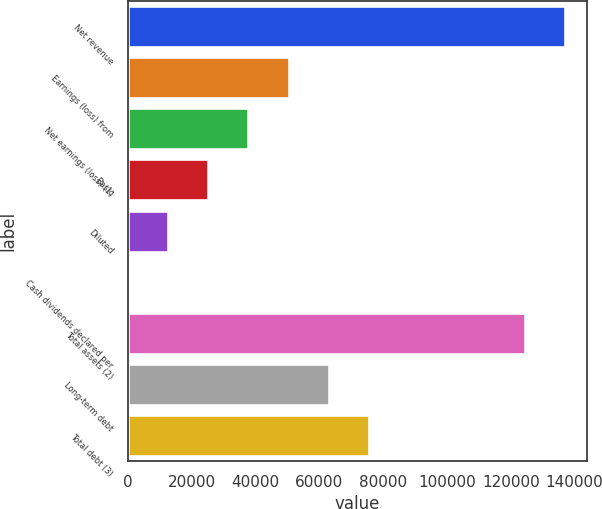Convert chart to OTSL. <chart><loc_0><loc_0><loc_500><loc_500><bar_chart><fcel>Net revenue<fcel>Earnings (loss) from<fcel>Net earnings (loss) (1)<fcel>Basic<fcel>Diluted<fcel>Cash dividends declared per<fcel>Total assets (2)<fcel>Long-term debt<fcel>Total debt (3)<nl><fcel>137106<fcel>50413.4<fcel>37810.1<fcel>25206.9<fcel>12603.6<fcel>0.32<fcel>124503<fcel>63016.7<fcel>75619.9<nl></chart> 